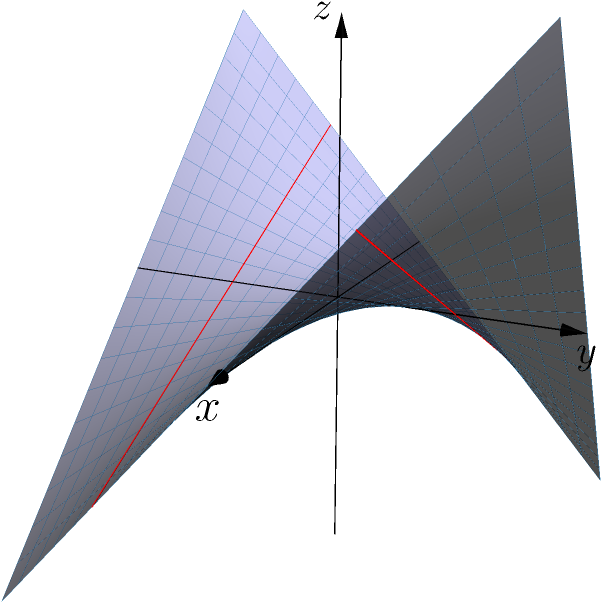On a hyperbolic paraboloid surface, represented by the equation $z = xy$, two lines are drawn parallel to the x-axis at $y = -1$ and $y = 1$. As a restoration expert accustomed to working with complex geometries, how would you characterize the relationship between these lines in this non-Euclidean space? To understand the relationship between these lines, let's approach this step-by-step:

1. The surface equation is $z = xy$, which defines a hyperbolic paraboloid or "saddle" shape.

2. The two lines are drawn at $y = -1$ and $y = 1$, parallel to the x-axis.

3. For the line at $y = -1$:
   The equation is $z = x(-1) = -x$

4. For the line at $y = 1$:
   The equation is $z = x(1) = x$

5. In Euclidean geometry, these lines would be parallel as they maintain a constant distance.

6. However, on this surface:
   - The line at $y = -1$ slopes downward as x increases.
   - The line at $y = 1$ slopes upward as x increases.

7. These lines are actually skew lines:
   - They are not parallel, as their slopes differ.
   - They do not intersect, as they exist on different parts of the surface.

8. In non-Euclidean geometry, specifically on this hyperbolic paraboloid, parallel lines can diverge, which is what we observe here.

This concept is crucial in understanding how "parallel" lines behave differently in non-Euclidean spaces, much like how restoration projects often require adapting standard techniques to unique, complex geometries.
Answer: Skew lines that diverge 